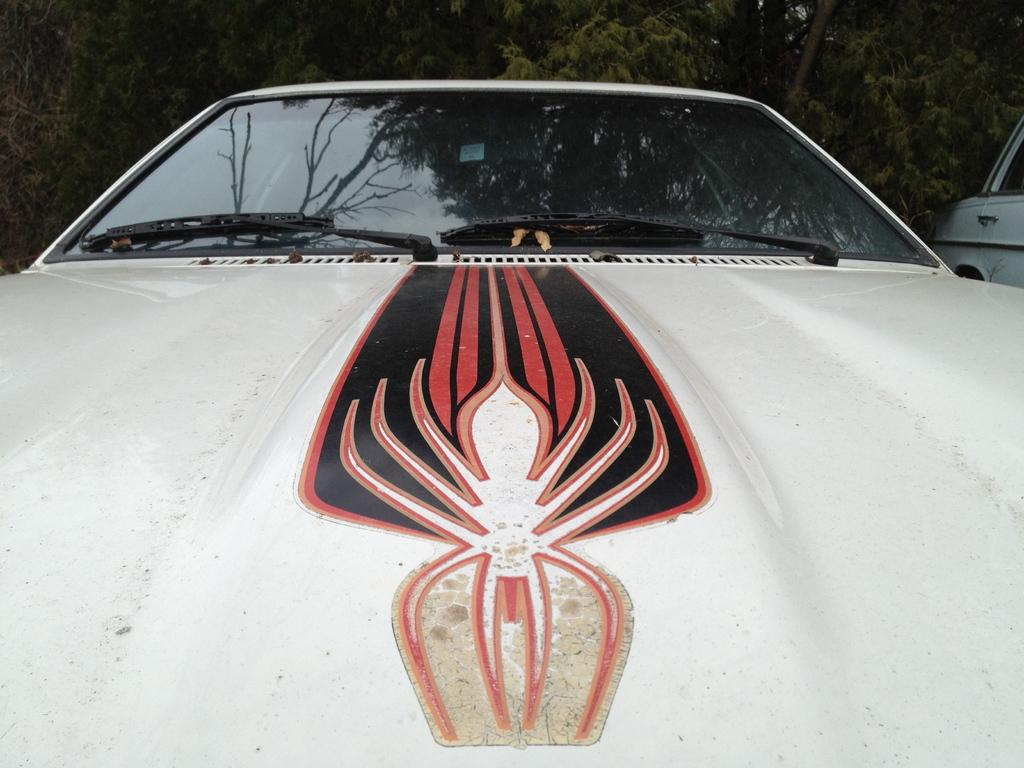What is the main subject of the image? The main subject of the image is a car. What can be seen on the car's bonnet? The car has a sticker on the bonnet. What color is the car? The car is white. What is visible in the background of the image? There are trees in the background of the image. Can you tell me how many birds are in the flock flying over the car in the image? There is no flock of birds visible in the image; it only features a car with a sticker on the bonnet, a white color, and trees in the background. 